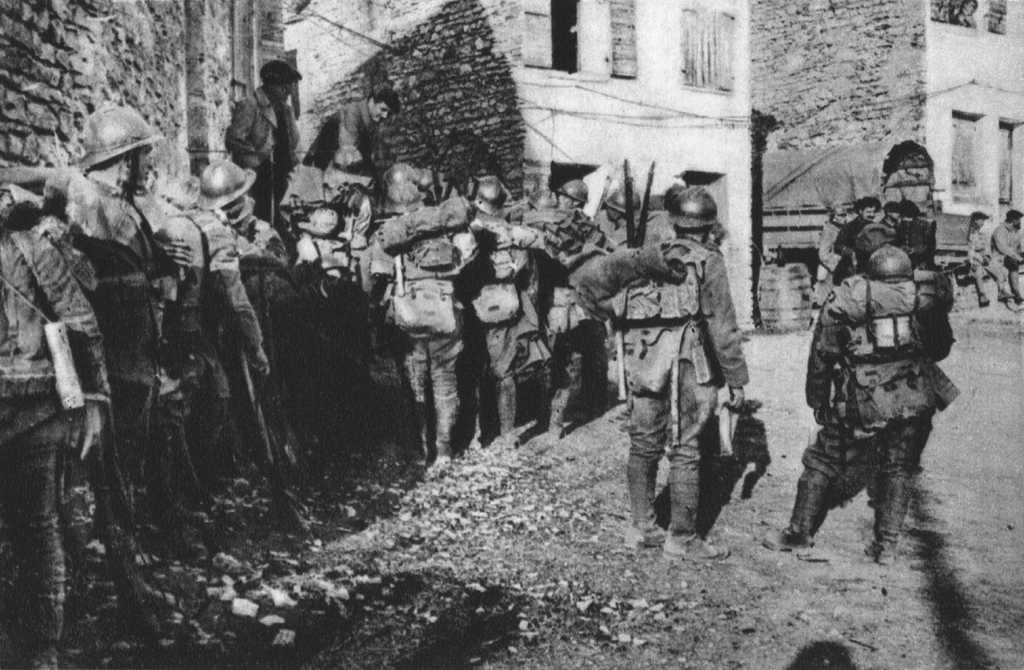Describe this image in one or two sentences. This is an old black and white image. There are groups of people standing. This looks like a vehicle, which is parked. These are the buildings with the windows. 